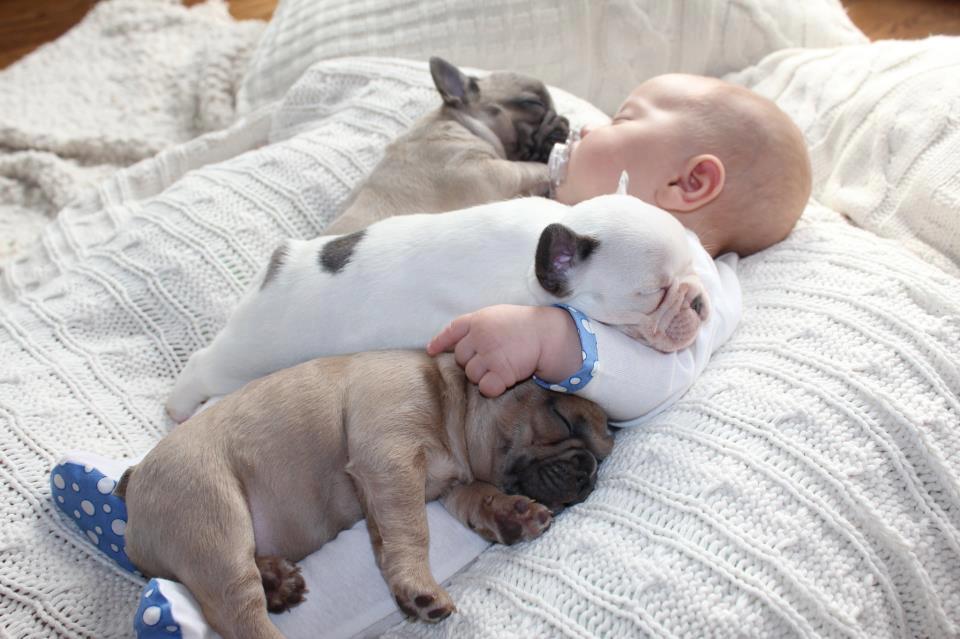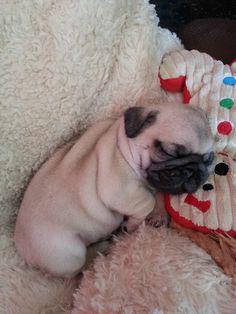The first image is the image on the left, the second image is the image on the right. Considering the images on both sides, is "The dogs in one of the images are sleeping on a baby." valid? Answer yes or no. Yes. The first image is the image on the left, the second image is the image on the right. Analyze the images presented: Is the assertion "An image shows two beige pug pups and a white spotted pug pup sleeping on top of a sleeping human baby." valid? Answer yes or no. Yes. 